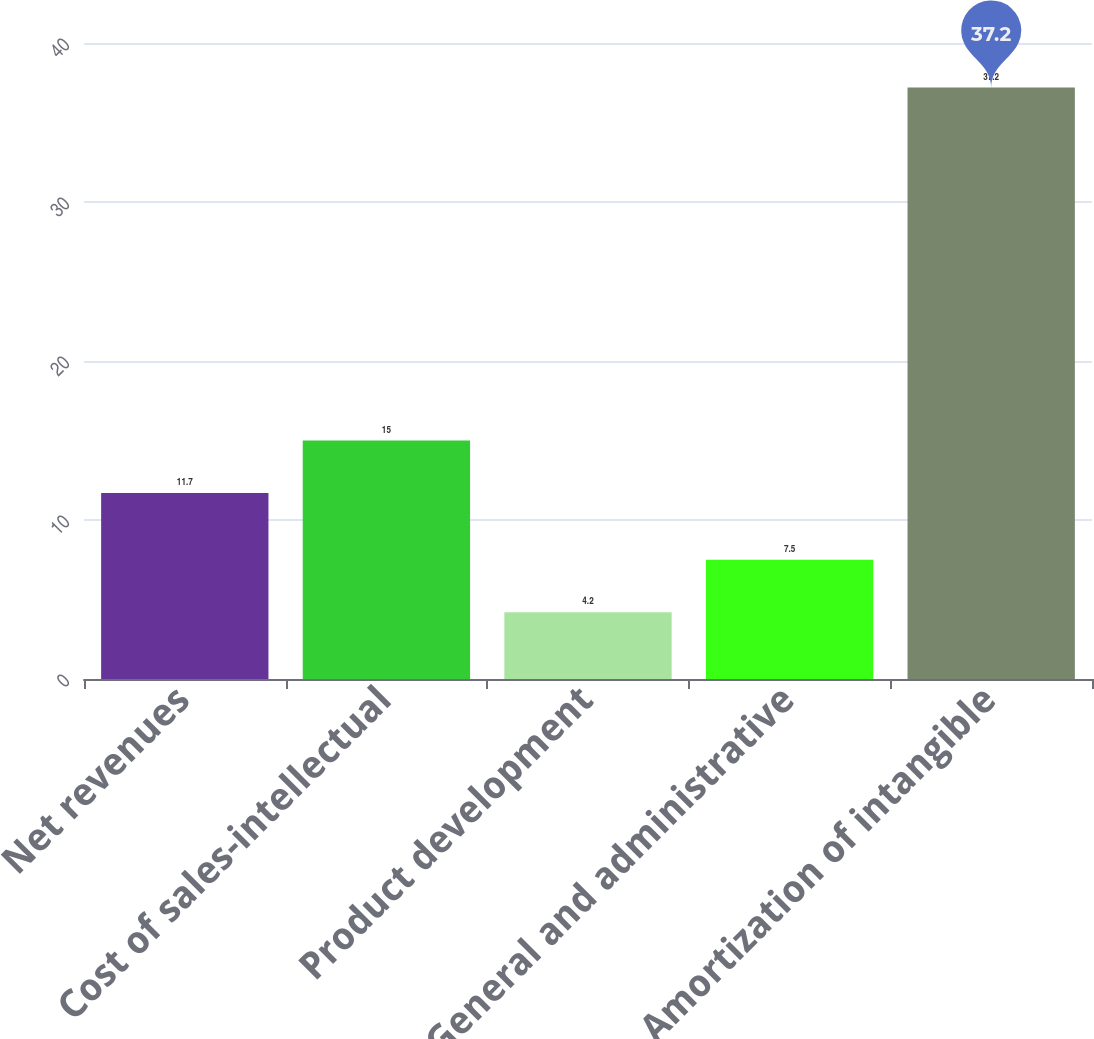Convert chart to OTSL. <chart><loc_0><loc_0><loc_500><loc_500><bar_chart><fcel>Net revenues<fcel>Cost of sales-intellectual<fcel>Product development<fcel>General and administrative<fcel>Amortization of intangible<nl><fcel>11.7<fcel>15<fcel>4.2<fcel>7.5<fcel>37.2<nl></chart> 